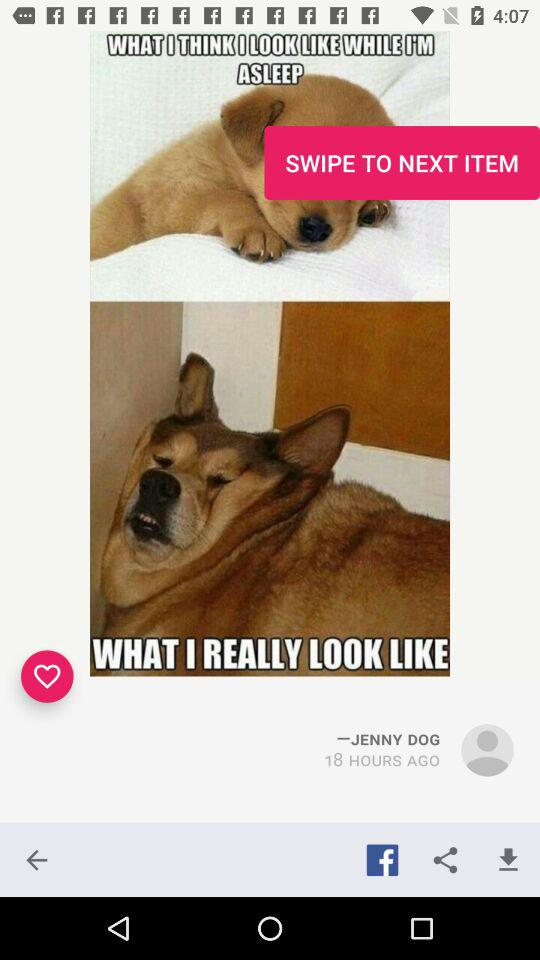How long ago was the photo uploaded? The photo was uploaded 18 hours ago. 